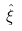<formula> <loc_0><loc_0><loc_500><loc_500>\hat { \xi }</formula> 